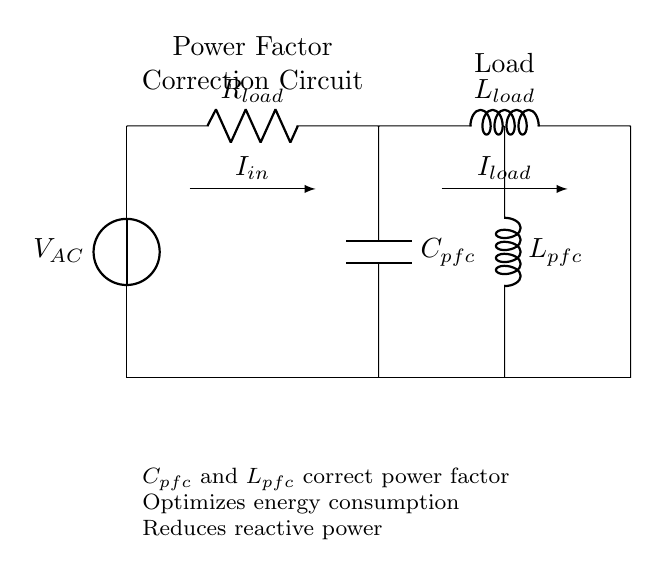What type of load is represented in this circuit? The circuit diagram includes a resistor and inductor in series, indicating the load type is a resistive-inductive load.
Answer: Resistive-inductive load What components are used for power factor correction? The components used for power factor correction are a capacitor and an inductor, specifically labeled as Cpfc and Lpfc.
Answer: Capacitor and inductor What is the role of the capacitor in this circuit? The capacitor corrects the power factor by compensating for the inductive reactance of the circuit, reducing reactive power.
Answer: Power factor correction How many key components are present in the circuit? The circuit consists of four main components: a resistor, an inductor (load), a capacitor (pfc), and an inductor (pfc).
Answer: Four What does the current labeled Iin represent? The current Iin represents the input current flowing into the circuit from the voltage source, powering the load and correction components.
Answer: Input current Why is it important to correct the power factor in manufacturing facilities? Correcting the power factor is crucial as it reduces the amount of reactive power, leading to more efficient energy consumption and lower electricity costs.
Answer: Efficient energy consumption 